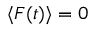<formula> <loc_0><loc_0><loc_500><loc_500>\langle F ( t ) \rangle = 0</formula> 